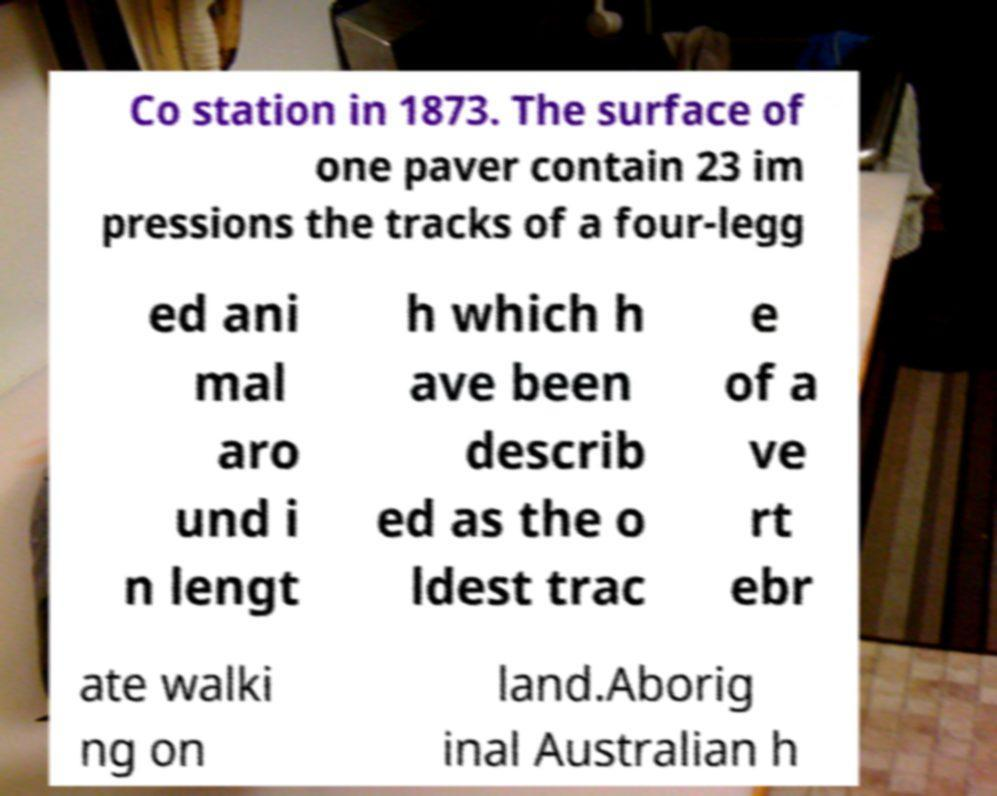Can you accurately transcribe the text from the provided image for me? Co station in 1873. The surface of one paver contain 23 im pressions the tracks of a four-legg ed ani mal aro und i n lengt h which h ave been describ ed as the o ldest trac e of a ve rt ebr ate walki ng on land.Aborig inal Australian h 